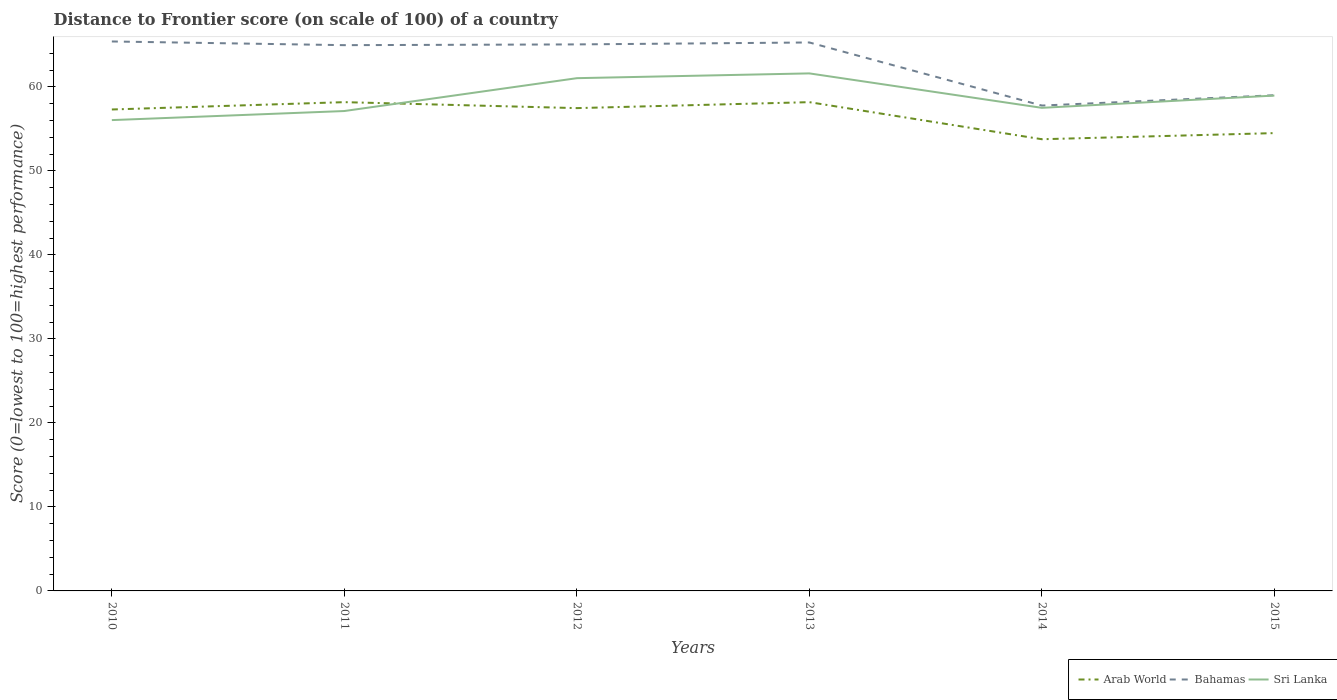Is the number of lines equal to the number of legend labels?
Provide a short and direct response. Yes. Across all years, what is the maximum distance to frontier score of in Arab World?
Your answer should be very brief. 53.76. In which year was the distance to frontier score of in Bahamas maximum?
Offer a very short reply. 2014. What is the total distance to frontier score of in Bahamas in the graph?
Give a very brief answer. 7.19. What is the difference between the highest and the second highest distance to frontier score of in Sri Lanka?
Keep it short and to the point. 5.56. Is the distance to frontier score of in Sri Lanka strictly greater than the distance to frontier score of in Arab World over the years?
Keep it short and to the point. No. How many years are there in the graph?
Make the answer very short. 6. Does the graph contain any zero values?
Your answer should be compact. No. Does the graph contain grids?
Provide a short and direct response. No. How are the legend labels stacked?
Make the answer very short. Horizontal. What is the title of the graph?
Offer a very short reply. Distance to Frontier score (on scale of 100) of a country. Does "South Asia" appear as one of the legend labels in the graph?
Your answer should be compact. No. What is the label or title of the X-axis?
Your response must be concise. Years. What is the label or title of the Y-axis?
Ensure brevity in your answer.  Score (0=lowest to 100=highest performance). What is the Score (0=lowest to 100=highest performance) of Arab World in 2010?
Your answer should be compact. 57.3. What is the Score (0=lowest to 100=highest performance) of Bahamas in 2010?
Your response must be concise. 65.4. What is the Score (0=lowest to 100=highest performance) in Sri Lanka in 2010?
Give a very brief answer. 56.04. What is the Score (0=lowest to 100=highest performance) of Arab World in 2011?
Keep it short and to the point. 58.18. What is the Score (0=lowest to 100=highest performance) in Bahamas in 2011?
Make the answer very short. 64.96. What is the Score (0=lowest to 100=highest performance) in Sri Lanka in 2011?
Make the answer very short. 57.12. What is the Score (0=lowest to 100=highest performance) in Arab World in 2012?
Offer a very short reply. 57.47. What is the Score (0=lowest to 100=highest performance) in Bahamas in 2012?
Offer a terse response. 65.05. What is the Score (0=lowest to 100=highest performance) in Sri Lanka in 2012?
Ensure brevity in your answer.  61.03. What is the Score (0=lowest to 100=highest performance) of Arab World in 2013?
Your answer should be compact. 58.18. What is the Score (0=lowest to 100=highest performance) of Bahamas in 2013?
Make the answer very short. 65.28. What is the Score (0=lowest to 100=highest performance) of Sri Lanka in 2013?
Provide a short and direct response. 61.6. What is the Score (0=lowest to 100=highest performance) of Arab World in 2014?
Keep it short and to the point. 53.76. What is the Score (0=lowest to 100=highest performance) of Bahamas in 2014?
Your answer should be very brief. 57.77. What is the Score (0=lowest to 100=highest performance) of Sri Lanka in 2014?
Make the answer very short. 57.5. What is the Score (0=lowest to 100=highest performance) of Arab World in 2015?
Your answer should be compact. 54.49. What is the Score (0=lowest to 100=highest performance) in Sri Lanka in 2015?
Offer a very short reply. 58.96. Across all years, what is the maximum Score (0=lowest to 100=highest performance) of Arab World?
Provide a short and direct response. 58.18. Across all years, what is the maximum Score (0=lowest to 100=highest performance) of Bahamas?
Offer a very short reply. 65.4. Across all years, what is the maximum Score (0=lowest to 100=highest performance) of Sri Lanka?
Give a very brief answer. 61.6. Across all years, what is the minimum Score (0=lowest to 100=highest performance) in Arab World?
Provide a succinct answer. 53.76. Across all years, what is the minimum Score (0=lowest to 100=highest performance) in Bahamas?
Keep it short and to the point. 57.77. Across all years, what is the minimum Score (0=lowest to 100=highest performance) in Sri Lanka?
Make the answer very short. 56.04. What is the total Score (0=lowest to 100=highest performance) in Arab World in the graph?
Offer a terse response. 339.38. What is the total Score (0=lowest to 100=highest performance) in Bahamas in the graph?
Make the answer very short. 377.46. What is the total Score (0=lowest to 100=highest performance) of Sri Lanka in the graph?
Keep it short and to the point. 352.25. What is the difference between the Score (0=lowest to 100=highest performance) in Arab World in 2010 and that in 2011?
Offer a very short reply. -0.87. What is the difference between the Score (0=lowest to 100=highest performance) of Bahamas in 2010 and that in 2011?
Ensure brevity in your answer.  0.44. What is the difference between the Score (0=lowest to 100=highest performance) of Sri Lanka in 2010 and that in 2011?
Your answer should be very brief. -1.08. What is the difference between the Score (0=lowest to 100=highest performance) of Arab World in 2010 and that in 2012?
Give a very brief answer. -0.16. What is the difference between the Score (0=lowest to 100=highest performance) of Sri Lanka in 2010 and that in 2012?
Give a very brief answer. -4.99. What is the difference between the Score (0=lowest to 100=highest performance) in Arab World in 2010 and that in 2013?
Your answer should be compact. -0.87. What is the difference between the Score (0=lowest to 100=highest performance) of Bahamas in 2010 and that in 2013?
Your answer should be compact. 0.12. What is the difference between the Score (0=lowest to 100=highest performance) of Sri Lanka in 2010 and that in 2013?
Give a very brief answer. -5.56. What is the difference between the Score (0=lowest to 100=highest performance) of Arab World in 2010 and that in 2014?
Offer a terse response. 3.54. What is the difference between the Score (0=lowest to 100=highest performance) in Bahamas in 2010 and that in 2014?
Provide a succinct answer. 7.63. What is the difference between the Score (0=lowest to 100=highest performance) in Sri Lanka in 2010 and that in 2014?
Your answer should be compact. -1.46. What is the difference between the Score (0=lowest to 100=highest performance) in Arab World in 2010 and that in 2015?
Make the answer very short. 2.81. What is the difference between the Score (0=lowest to 100=highest performance) of Bahamas in 2010 and that in 2015?
Your answer should be very brief. 6.4. What is the difference between the Score (0=lowest to 100=highest performance) of Sri Lanka in 2010 and that in 2015?
Provide a succinct answer. -2.92. What is the difference between the Score (0=lowest to 100=highest performance) in Arab World in 2011 and that in 2012?
Make the answer very short. 0.71. What is the difference between the Score (0=lowest to 100=highest performance) of Bahamas in 2011 and that in 2012?
Give a very brief answer. -0.09. What is the difference between the Score (0=lowest to 100=highest performance) in Sri Lanka in 2011 and that in 2012?
Offer a very short reply. -3.91. What is the difference between the Score (0=lowest to 100=highest performance) in Arab World in 2011 and that in 2013?
Ensure brevity in your answer.  0. What is the difference between the Score (0=lowest to 100=highest performance) in Bahamas in 2011 and that in 2013?
Your answer should be very brief. -0.32. What is the difference between the Score (0=lowest to 100=highest performance) of Sri Lanka in 2011 and that in 2013?
Offer a terse response. -4.48. What is the difference between the Score (0=lowest to 100=highest performance) of Arab World in 2011 and that in 2014?
Provide a succinct answer. 4.41. What is the difference between the Score (0=lowest to 100=highest performance) in Bahamas in 2011 and that in 2014?
Provide a short and direct response. 7.19. What is the difference between the Score (0=lowest to 100=highest performance) in Sri Lanka in 2011 and that in 2014?
Provide a succinct answer. -0.38. What is the difference between the Score (0=lowest to 100=highest performance) in Arab World in 2011 and that in 2015?
Your answer should be compact. 3.68. What is the difference between the Score (0=lowest to 100=highest performance) in Bahamas in 2011 and that in 2015?
Your answer should be compact. 5.96. What is the difference between the Score (0=lowest to 100=highest performance) in Sri Lanka in 2011 and that in 2015?
Provide a short and direct response. -1.84. What is the difference between the Score (0=lowest to 100=highest performance) in Arab World in 2012 and that in 2013?
Offer a terse response. -0.71. What is the difference between the Score (0=lowest to 100=highest performance) of Bahamas in 2012 and that in 2013?
Your response must be concise. -0.23. What is the difference between the Score (0=lowest to 100=highest performance) in Sri Lanka in 2012 and that in 2013?
Provide a short and direct response. -0.57. What is the difference between the Score (0=lowest to 100=highest performance) in Arab World in 2012 and that in 2014?
Give a very brief answer. 3.7. What is the difference between the Score (0=lowest to 100=highest performance) in Bahamas in 2012 and that in 2014?
Offer a very short reply. 7.28. What is the difference between the Score (0=lowest to 100=highest performance) of Sri Lanka in 2012 and that in 2014?
Ensure brevity in your answer.  3.53. What is the difference between the Score (0=lowest to 100=highest performance) of Arab World in 2012 and that in 2015?
Your answer should be compact. 2.97. What is the difference between the Score (0=lowest to 100=highest performance) of Bahamas in 2012 and that in 2015?
Offer a very short reply. 6.05. What is the difference between the Score (0=lowest to 100=highest performance) in Sri Lanka in 2012 and that in 2015?
Keep it short and to the point. 2.07. What is the difference between the Score (0=lowest to 100=highest performance) in Arab World in 2013 and that in 2014?
Your response must be concise. 4.41. What is the difference between the Score (0=lowest to 100=highest performance) in Bahamas in 2013 and that in 2014?
Give a very brief answer. 7.51. What is the difference between the Score (0=lowest to 100=highest performance) in Arab World in 2013 and that in 2015?
Your answer should be compact. 3.68. What is the difference between the Score (0=lowest to 100=highest performance) in Bahamas in 2013 and that in 2015?
Your answer should be very brief. 6.28. What is the difference between the Score (0=lowest to 100=highest performance) of Sri Lanka in 2013 and that in 2015?
Your answer should be compact. 2.64. What is the difference between the Score (0=lowest to 100=highest performance) of Arab World in 2014 and that in 2015?
Offer a terse response. -0.73. What is the difference between the Score (0=lowest to 100=highest performance) of Bahamas in 2014 and that in 2015?
Offer a terse response. -1.23. What is the difference between the Score (0=lowest to 100=highest performance) in Sri Lanka in 2014 and that in 2015?
Provide a short and direct response. -1.46. What is the difference between the Score (0=lowest to 100=highest performance) of Arab World in 2010 and the Score (0=lowest to 100=highest performance) of Bahamas in 2011?
Provide a succinct answer. -7.66. What is the difference between the Score (0=lowest to 100=highest performance) in Arab World in 2010 and the Score (0=lowest to 100=highest performance) in Sri Lanka in 2011?
Provide a short and direct response. 0.18. What is the difference between the Score (0=lowest to 100=highest performance) of Bahamas in 2010 and the Score (0=lowest to 100=highest performance) of Sri Lanka in 2011?
Provide a short and direct response. 8.28. What is the difference between the Score (0=lowest to 100=highest performance) in Arab World in 2010 and the Score (0=lowest to 100=highest performance) in Bahamas in 2012?
Offer a very short reply. -7.75. What is the difference between the Score (0=lowest to 100=highest performance) of Arab World in 2010 and the Score (0=lowest to 100=highest performance) of Sri Lanka in 2012?
Your answer should be compact. -3.73. What is the difference between the Score (0=lowest to 100=highest performance) in Bahamas in 2010 and the Score (0=lowest to 100=highest performance) in Sri Lanka in 2012?
Your answer should be very brief. 4.37. What is the difference between the Score (0=lowest to 100=highest performance) in Arab World in 2010 and the Score (0=lowest to 100=highest performance) in Bahamas in 2013?
Give a very brief answer. -7.98. What is the difference between the Score (0=lowest to 100=highest performance) in Arab World in 2010 and the Score (0=lowest to 100=highest performance) in Sri Lanka in 2013?
Ensure brevity in your answer.  -4.3. What is the difference between the Score (0=lowest to 100=highest performance) in Bahamas in 2010 and the Score (0=lowest to 100=highest performance) in Sri Lanka in 2013?
Ensure brevity in your answer.  3.8. What is the difference between the Score (0=lowest to 100=highest performance) in Arab World in 2010 and the Score (0=lowest to 100=highest performance) in Bahamas in 2014?
Your response must be concise. -0.47. What is the difference between the Score (0=lowest to 100=highest performance) of Arab World in 2010 and the Score (0=lowest to 100=highest performance) of Sri Lanka in 2014?
Provide a succinct answer. -0.2. What is the difference between the Score (0=lowest to 100=highest performance) in Bahamas in 2010 and the Score (0=lowest to 100=highest performance) in Sri Lanka in 2014?
Offer a terse response. 7.9. What is the difference between the Score (0=lowest to 100=highest performance) of Arab World in 2010 and the Score (0=lowest to 100=highest performance) of Bahamas in 2015?
Make the answer very short. -1.7. What is the difference between the Score (0=lowest to 100=highest performance) of Arab World in 2010 and the Score (0=lowest to 100=highest performance) of Sri Lanka in 2015?
Your answer should be very brief. -1.66. What is the difference between the Score (0=lowest to 100=highest performance) in Bahamas in 2010 and the Score (0=lowest to 100=highest performance) in Sri Lanka in 2015?
Your answer should be compact. 6.44. What is the difference between the Score (0=lowest to 100=highest performance) of Arab World in 2011 and the Score (0=lowest to 100=highest performance) of Bahamas in 2012?
Provide a succinct answer. -6.87. What is the difference between the Score (0=lowest to 100=highest performance) of Arab World in 2011 and the Score (0=lowest to 100=highest performance) of Sri Lanka in 2012?
Ensure brevity in your answer.  -2.85. What is the difference between the Score (0=lowest to 100=highest performance) of Bahamas in 2011 and the Score (0=lowest to 100=highest performance) of Sri Lanka in 2012?
Your response must be concise. 3.93. What is the difference between the Score (0=lowest to 100=highest performance) of Arab World in 2011 and the Score (0=lowest to 100=highest performance) of Bahamas in 2013?
Make the answer very short. -7.1. What is the difference between the Score (0=lowest to 100=highest performance) of Arab World in 2011 and the Score (0=lowest to 100=highest performance) of Sri Lanka in 2013?
Offer a very short reply. -3.42. What is the difference between the Score (0=lowest to 100=highest performance) in Bahamas in 2011 and the Score (0=lowest to 100=highest performance) in Sri Lanka in 2013?
Your answer should be very brief. 3.36. What is the difference between the Score (0=lowest to 100=highest performance) of Arab World in 2011 and the Score (0=lowest to 100=highest performance) of Bahamas in 2014?
Offer a very short reply. 0.41. What is the difference between the Score (0=lowest to 100=highest performance) in Arab World in 2011 and the Score (0=lowest to 100=highest performance) in Sri Lanka in 2014?
Offer a very short reply. 0.68. What is the difference between the Score (0=lowest to 100=highest performance) in Bahamas in 2011 and the Score (0=lowest to 100=highest performance) in Sri Lanka in 2014?
Provide a succinct answer. 7.46. What is the difference between the Score (0=lowest to 100=highest performance) of Arab World in 2011 and the Score (0=lowest to 100=highest performance) of Bahamas in 2015?
Make the answer very short. -0.82. What is the difference between the Score (0=lowest to 100=highest performance) of Arab World in 2011 and the Score (0=lowest to 100=highest performance) of Sri Lanka in 2015?
Make the answer very short. -0.78. What is the difference between the Score (0=lowest to 100=highest performance) in Bahamas in 2011 and the Score (0=lowest to 100=highest performance) in Sri Lanka in 2015?
Ensure brevity in your answer.  6. What is the difference between the Score (0=lowest to 100=highest performance) of Arab World in 2012 and the Score (0=lowest to 100=highest performance) of Bahamas in 2013?
Keep it short and to the point. -7.81. What is the difference between the Score (0=lowest to 100=highest performance) of Arab World in 2012 and the Score (0=lowest to 100=highest performance) of Sri Lanka in 2013?
Your answer should be very brief. -4.13. What is the difference between the Score (0=lowest to 100=highest performance) in Bahamas in 2012 and the Score (0=lowest to 100=highest performance) in Sri Lanka in 2013?
Offer a very short reply. 3.45. What is the difference between the Score (0=lowest to 100=highest performance) in Arab World in 2012 and the Score (0=lowest to 100=highest performance) in Bahamas in 2014?
Give a very brief answer. -0.3. What is the difference between the Score (0=lowest to 100=highest performance) in Arab World in 2012 and the Score (0=lowest to 100=highest performance) in Sri Lanka in 2014?
Ensure brevity in your answer.  -0.03. What is the difference between the Score (0=lowest to 100=highest performance) in Bahamas in 2012 and the Score (0=lowest to 100=highest performance) in Sri Lanka in 2014?
Make the answer very short. 7.55. What is the difference between the Score (0=lowest to 100=highest performance) of Arab World in 2012 and the Score (0=lowest to 100=highest performance) of Bahamas in 2015?
Offer a very short reply. -1.53. What is the difference between the Score (0=lowest to 100=highest performance) of Arab World in 2012 and the Score (0=lowest to 100=highest performance) of Sri Lanka in 2015?
Make the answer very short. -1.49. What is the difference between the Score (0=lowest to 100=highest performance) of Bahamas in 2012 and the Score (0=lowest to 100=highest performance) of Sri Lanka in 2015?
Your answer should be compact. 6.09. What is the difference between the Score (0=lowest to 100=highest performance) in Arab World in 2013 and the Score (0=lowest to 100=highest performance) in Bahamas in 2014?
Keep it short and to the point. 0.41. What is the difference between the Score (0=lowest to 100=highest performance) in Arab World in 2013 and the Score (0=lowest to 100=highest performance) in Sri Lanka in 2014?
Offer a terse response. 0.68. What is the difference between the Score (0=lowest to 100=highest performance) in Bahamas in 2013 and the Score (0=lowest to 100=highest performance) in Sri Lanka in 2014?
Keep it short and to the point. 7.78. What is the difference between the Score (0=lowest to 100=highest performance) in Arab World in 2013 and the Score (0=lowest to 100=highest performance) in Bahamas in 2015?
Make the answer very short. -0.82. What is the difference between the Score (0=lowest to 100=highest performance) of Arab World in 2013 and the Score (0=lowest to 100=highest performance) of Sri Lanka in 2015?
Offer a terse response. -0.78. What is the difference between the Score (0=lowest to 100=highest performance) of Bahamas in 2013 and the Score (0=lowest to 100=highest performance) of Sri Lanka in 2015?
Provide a short and direct response. 6.32. What is the difference between the Score (0=lowest to 100=highest performance) in Arab World in 2014 and the Score (0=lowest to 100=highest performance) in Bahamas in 2015?
Offer a terse response. -5.24. What is the difference between the Score (0=lowest to 100=highest performance) of Arab World in 2014 and the Score (0=lowest to 100=highest performance) of Sri Lanka in 2015?
Provide a succinct answer. -5.2. What is the difference between the Score (0=lowest to 100=highest performance) in Bahamas in 2014 and the Score (0=lowest to 100=highest performance) in Sri Lanka in 2015?
Your answer should be compact. -1.19. What is the average Score (0=lowest to 100=highest performance) of Arab World per year?
Ensure brevity in your answer.  56.56. What is the average Score (0=lowest to 100=highest performance) of Bahamas per year?
Give a very brief answer. 62.91. What is the average Score (0=lowest to 100=highest performance) in Sri Lanka per year?
Your answer should be compact. 58.71. In the year 2010, what is the difference between the Score (0=lowest to 100=highest performance) in Arab World and Score (0=lowest to 100=highest performance) in Bahamas?
Your answer should be compact. -8.1. In the year 2010, what is the difference between the Score (0=lowest to 100=highest performance) of Arab World and Score (0=lowest to 100=highest performance) of Sri Lanka?
Provide a short and direct response. 1.26. In the year 2010, what is the difference between the Score (0=lowest to 100=highest performance) in Bahamas and Score (0=lowest to 100=highest performance) in Sri Lanka?
Provide a short and direct response. 9.36. In the year 2011, what is the difference between the Score (0=lowest to 100=highest performance) of Arab World and Score (0=lowest to 100=highest performance) of Bahamas?
Your response must be concise. -6.78. In the year 2011, what is the difference between the Score (0=lowest to 100=highest performance) in Arab World and Score (0=lowest to 100=highest performance) in Sri Lanka?
Keep it short and to the point. 1.06. In the year 2011, what is the difference between the Score (0=lowest to 100=highest performance) of Bahamas and Score (0=lowest to 100=highest performance) of Sri Lanka?
Give a very brief answer. 7.84. In the year 2012, what is the difference between the Score (0=lowest to 100=highest performance) in Arab World and Score (0=lowest to 100=highest performance) in Bahamas?
Your answer should be very brief. -7.58. In the year 2012, what is the difference between the Score (0=lowest to 100=highest performance) in Arab World and Score (0=lowest to 100=highest performance) in Sri Lanka?
Offer a terse response. -3.56. In the year 2012, what is the difference between the Score (0=lowest to 100=highest performance) of Bahamas and Score (0=lowest to 100=highest performance) of Sri Lanka?
Keep it short and to the point. 4.02. In the year 2013, what is the difference between the Score (0=lowest to 100=highest performance) of Arab World and Score (0=lowest to 100=highest performance) of Bahamas?
Offer a terse response. -7.1. In the year 2013, what is the difference between the Score (0=lowest to 100=highest performance) in Arab World and Score (0=lowest to 100=highest performance) in Sri Lanka?
Keep it short and to the point. -3.42. In the year 2013, what is the difference between the Score (0=lowest to 100=highest performance) of Bahamas and Score (0=lowest to 100=highest performance) of Sri Lanka?
Keep it short and to the point. 3.68. In the year 2014, what is the difference between the Score (0=lowest to 100=highest performance) in Arab World and Score (0=lowest to 100=highest performance) in Bahamas?
Give a very brief answer. -4.01. In the year 2014, what is the difference between the Score (0=lowest to 100=highest performance) in Arab World and Score (0=lowest to 100=highest performance) in Sri Lanka?
Your answer should be compact. -3.74. In the year 2014, what is the difference between the Score (0=lowest to 100=highest performance) in Bahamas and Score (0=lowest to 100=highest performance) in Sri Lanka?
Give a very brief answer. 0.27. In the year 2015, what is the difference between the Score (0=lowest to 100=highest performance) in Arab World and Score (0=lowest to 100=highest performance) in Bahamas?
Your answer should be compact. -4.51. In the year 2015, what is the difference between the Score (0=lowest to 100=highest performance) in Arab World and Score (0=lowest to 100=highest performance) in Sri Lanka?
Offer a terse response. -4.47. In the year 2015, what is the difference between the Score (0=lowest to 100=highest performance) in Bahamas and Score (0=lowest to 100=highest performance) in Sri Lanka?
Your answer should be very brief. 0.04. What is the ratio of the Score (0=lowest to 100=highest performance) in Bahamas in 2010 to that in 2011?
Provide a succinct answer. 1.01. What is the ratio of the Score (0=lowest to 100=highest performance) in Sri Lanka in 2010 to that in 2011?
Your answer should be very brief. 0.98. What is the ratio of the Score (0=lowest to 100=highest performance) in Arab World in 2010 to that in 2012?
Provide a short and direct response. 1. What is the ratio of the Score (0=lowest to 100=highest performance) of Bahamas in 2010 to that in 2012?
Offer a very short reply. 1.01. What is the ratio of the Score (0=lowest to 100=highest performance) of Sri Lanka in 2010 to that in 2012?
Offer a very short reply. 0.92. What is the ratio of the Score (0=lowest to 100=highest performance) in Arab World in 2010 to that in 2013?
Your answer should be very brief. 0.98. What is the ratio of the Score (0=lowest to 100=highest performance) in Sri Lanka in 2010 to that in 2013?
Provide a succinct answer. 0.91. What is the ratio of the Score (0=lowest to 100=highest performance) in Arab World in 2010 to that in 2014?
Your answer should be compact. 1.07. What is the ratio of the Score (0=lowest to 100=highest performance) of Bahamas in 2010 to that in 2014?
Provide a short and direct response. 1.13. What is the ratio of the Score (0=lowest to 100=highest performance) of Sri Lanka in 2010 to that in 2014?
Make the answer very short. 0.97. What is the ratio of the Score (0=lowest to 100=highest performance) of Arab World in 2010 to that in 2015?
Your answer should be very brief. 1.05. What is the ratio of the Score (0=lowest to 100=highest performance) of Bahamas in 2010 to that in 2015?
Provide a short and direct response. 1.11. What is the ratio of the Score (0=lowest to 100=highest performance) of Sri Lanka in 2010 to that in 2015?
Make the answer very short. 0.95. What is the ratio of the Score (0=lowest to 100=highest performance) in Arab World in 2011 to that in 2012?
Give a very brief answer. 1.01. What is the ratio of the Score (0=lowest to 100=highest performance) in Sri Lanka in 2011 to that in 2012?
Your answer should be very brief. 0.94. What is the ratio of the Score (0=lowest to 100=highest performance) in Bahamas in 2011 to that in 2013?
Provide a short and direct response. 1. What is the ratio of the Score (0=lowest to 100=highest performance) of Sri Lanka in 2011 to that in 2013?
Your answer should be very brief. 0.93. What is the ratio of the Score (0=lowest to 100=highest performance) of Arab World in 2011 to that in 2014?
Provide a short and direct response. 1.08. What is the ratio of the Score (0=lowest to 100=highest performance) of Bahamas in 2011 to that in 2014?
Make the answer very short. 1.12. What is the ratio of the Score (0=lowest to 100=highest performance) of Sri Lanka in 2011 to that in 2014?
Ensure brevity in your answer.  0.99. What is the ratio of the Score (0=lowest to 100=highest performance) in Arab World in 2011 to that in 2015?
Keep it short and to the point. 1.07. What is the ratio of the Score (0=lowest to 100=highest performance) of Bahamas in 2011 to that in 2015?
Your answer should be compact. 1.1. What is the ratio of the Score (0=lowest to 100=highest performance) of Sri Lanka in 2011 to that in 2015?
Your response must be concise. 0.97. What is the ratio of the Score (0=lowest to 100=highest performance) of Arab World in 2012 to that in 2013?
Your answer should be compact. 0.99. What is the ratio of the Score (0=lowest to 100=highest performance) of Bahamas in 2012 to that in 2013?
Offer a terse response. 1. What is the ratio of the Score (0=lowest to 100=highest performance) of Arab World in 2012 to that in 2014?
Offer a terse response. 1.07. What is the ratio of the Score (0=lowest to 100=highest performance) in Bahamas in 2012 to that in 2014?
Keep it short and to the point. 1.13. What is the ratio of the Score (0=lowest to 100=highest performance) in Sri Lanka in 2012 to that in 2014?
Make the answer very short. 1.06. What is the ratio of the Score (0=lowest to 100=highest performance) in Arab World in 2012 to that in 2015?
Give a very brief answer. 1.05. What is the ratio of the Score (0=lowest to 100=highest performance) of Bahamas in 2012 to that in 2015?
Ensure brevity in your answer.  1.1. What is the ratio of the Score (0=lowest to 100=highest performance) in Sri Lanka in 2012 to that in 2015?
Provide a short and direct response. 1.04. What is the ratio of the Score (0=lowest to 100=highest performance) of Arab World in 2013 to that in 2014?
Your answer should be very brief. 1.08. What is the ratio of the Score (0=lowest to 100=highest performance) in Bahamas in 2013 to that in 2014?
Provide a short and direct response. 1.13. What is the ratio of the Score (0=lowest to 100=highest performance) in Sri Lanka in 2013 to that in 2014?
Offer a very short reply. 1.07. What is the ratio of the Score (0=lowest to 100=highest performance) in Arab World in 2013 to that in 2015?
Provide a short and direct response. 1.07. What is the ratio of the Score (0=lowest to 100=highest performance) of Bahamas in 2013 to that in 2015?
Provide a succinct answer. 1.11. What is the ratio of the Score (0=lowest to 100=highest performance) of Sri Lanka in 2013 to that in 2015?
Provide a succinct answer. 1.04. What is the ratio of the Score (0=lowest to 100=highest performance) of Arab World in 2014 to that in 2015?
Your answer should be very brief. 0.99. What is the ratio of the Score (0=lowest to 100=highest performance) of Bahamas in 2014 to that in 2015?
Give a very brief answer. 0.98. What is the ratio of the Score (0=lowest to 100=highest performance) of Sri Lanka in 2014 to that in 2015?
Make the answer very short. 0.98. What is the difference between the highest and the second highest Score (0=lowest to 100=highest performance) of Arab World?
Your answer should be compact. 0. What is the difference between the highest and the second highest Score (0=lowest to 100=highest performance) of Bahamas?
Ensure brevity in your answer.  0.12. What is the difference between the highest and the second highest Score (0=lowest to 100=highest performance) in Sri Lanka?
Provide a short and direct response. 0.57. What is the difference between the highest and the lowest Score (0=lowest to 100=highest performance) in Arab World?
Ensure brevity in your answer.  4.41. What is the difference between the highest and the lowest Score (0=lowest to 100=highest performance) of Bahamas?
Give a very brief answer. 7.63. What is the difference between the highest and the lowest Score (0=lowest to 100=highest performance) of Sri Lanka?
Keep it short and to the point. 5.56. 